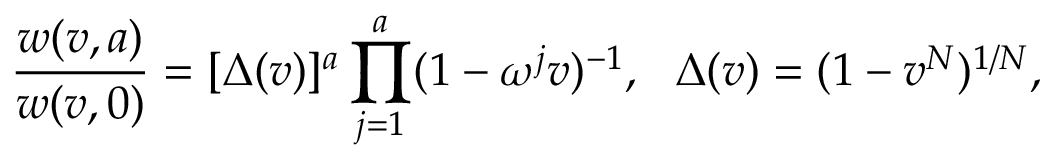<formula> <loc_0><loc_0><loc_500><loc_500>{ \frac { w ( v , a ) } { w ( v , 0 ) } } = [ \Delta ( v ) ] ^ { a } \prod _ { j = 1 } ^ { a } ( 1 - \omega ^ { j } v ) ^ { - 1 } \Delta ( v ) = ( 1 - v ^ { N } ) ^ { 1 / N } ,</formula> 